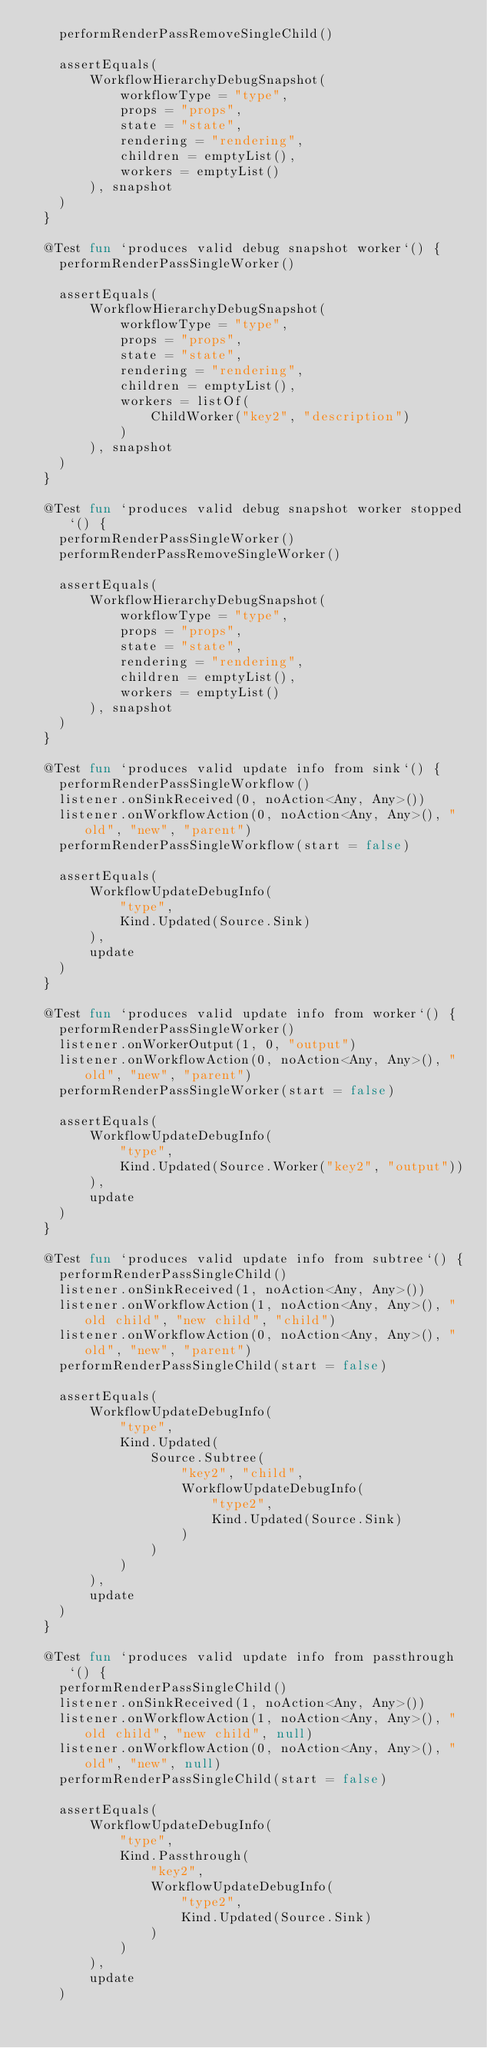<code> <loc_0><loc_0><loc_500><loc_500><_Kotlin_>    performRenderPassRemoveSingleChild()

    assertEquals(
        WorkflowHierarchyDebugSnapshot(
            workflowType = "type",
            props = "props",
            state = "state",
            rendering = "rendering",
            children = emptyList(),
            workers = emptyList()
        ), snapshot
    )
  }

  @Test fun `produces valid debug snapshot worker`() {
    performRenderPassSingleWorker()

    assertEquals(
        WorkflowHierarchyDebugSnapshot(
            workflowType = "type",
            props = "props",
            state = "state",
            rendering = "rendering",
            children = emptyList(),
            workers = listOf(
                ChildWorker("key2", "description")
            )
        ), snapshot
    )
  }

  @Test fun `produces valid debug snapshot worker stopped`() {
    performRenderPassSingleWorker()
    performRenderPassRemoveSingleWorker()

    assertEquals(
        WorkflowHierarchyDebugSnapshot(
            workflowType = "type",
            props = "props",
            state = "state",
            rendering = "rendering",
            children = emptyList(),
            workers = emptyList()
        ), snapshot
    )
  }

  @Test fun `produces valid update info from sink`() {
    performRenderPassSingleWorkflow()
    listener.onSinkReceived(0, noAction<Any, Any>())
    listener.onWorkflowAction(0, noAction<Any, Any>(), "old", "new", "parent")
    performRenderPassSingleWorkflow(start = false)

    assertEquals(
        WorkflowUpdateDebugInfo(
            "type",
            Kind.Updated(Source.Sink)
        ),
        update
    )
  }

  @Test fun `produces valid update info from worker`() {
    performRenderPassSingleWorker()
    listener.onWorkerOutput(1, 0, "output")
    listener.onWorkflowAction(0, noAction<Any, Any>(), "old", "new", "parent")
    performRenderPassSingleWorker(start = false)

    assertEquals(
        WorkflowUpdateDebugInfo(
            "type",
            Kind.Updated(Source.Worker("key2", "output"))
        ),
        update
    )
  }

  @Test fun `produces valid update info from subtree`() {
    performRenderPassSingleChild()
    listener.onSinkReceived(1, noAction<Any, Any>())
    listener.onWorkflowAction(1, noAction<Any, Any>(), "old child", "new child", "child")
    listener.onWorkflowAction(0, noAction<Any, Any>(), "old", "new", "parent")
    performRenderPassSingleChild(start = false)

    assertEquals(
        WorkflowUpdateDebugInfo(
            "type",
            Kind.Updated(
                Source.Subtree(
                    "key2", "child",
                    WorkflowUpdateDebugInfo(
                        "type2",
                        Kind.Updated(Source.Sink)
                    )
                )
            )
        ),
        update
    )
  }

  @Test fun `produces valid update info from passthrough`() {
    performRenderPassSingleChild()
    listener.onSinkReceived(1, noAction<Any, Any>())
    listener.onWorkflowAction(1, noAction<Any, Any>(), "old child", "new child", null)
    listener.onWorkflowAction(0, noAction<Any, Any>(), "old", "new", null)
    performRenderPassSingleChild(start = false)

    assertEquals(
        WorkflowUpdateDebugInfo(
            "type",
            Kind.Passthrough(
                "key2",
                WorkflowUpdateDebugInfo(
                    "type2",
                    Kind.Updated(Source.Sink)
                )
            )
        ),
        update
    )</code> 